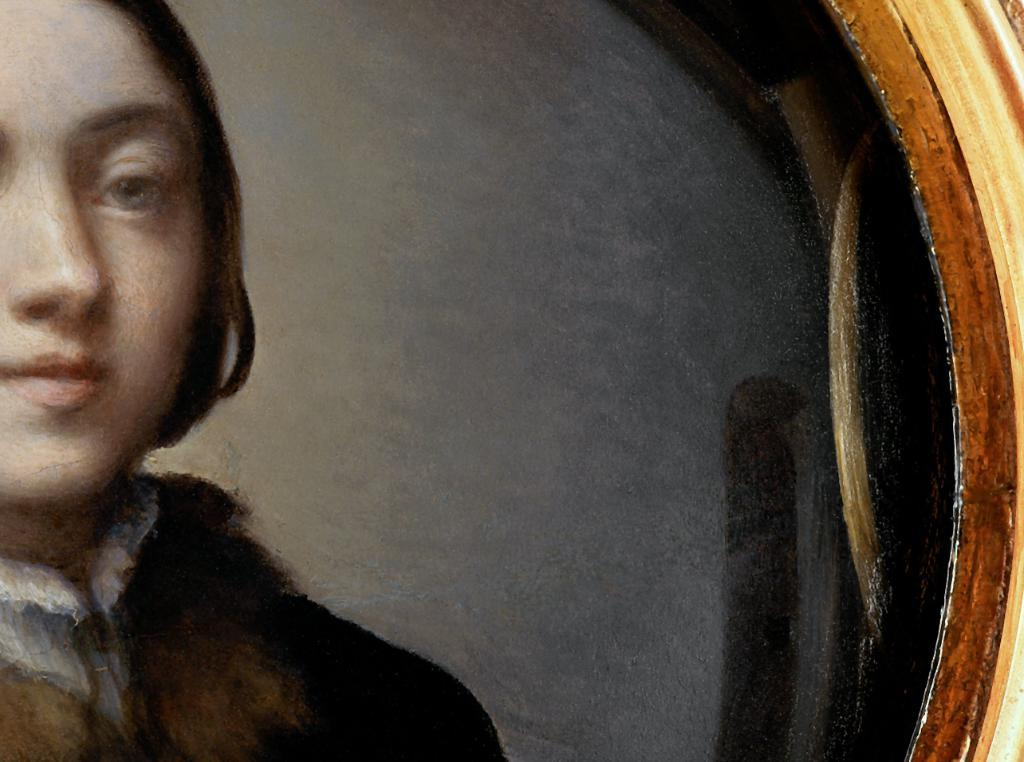What type of artwork is shown in the image? The image is a painting. What subject matter is depicted in the painting? The painting depicts a female character. How many rings does the female character have on her fingers in the painting? There is no information about rings or fingers in the provided facts, so we cannot determine the number of rings on the female character's fingers. 